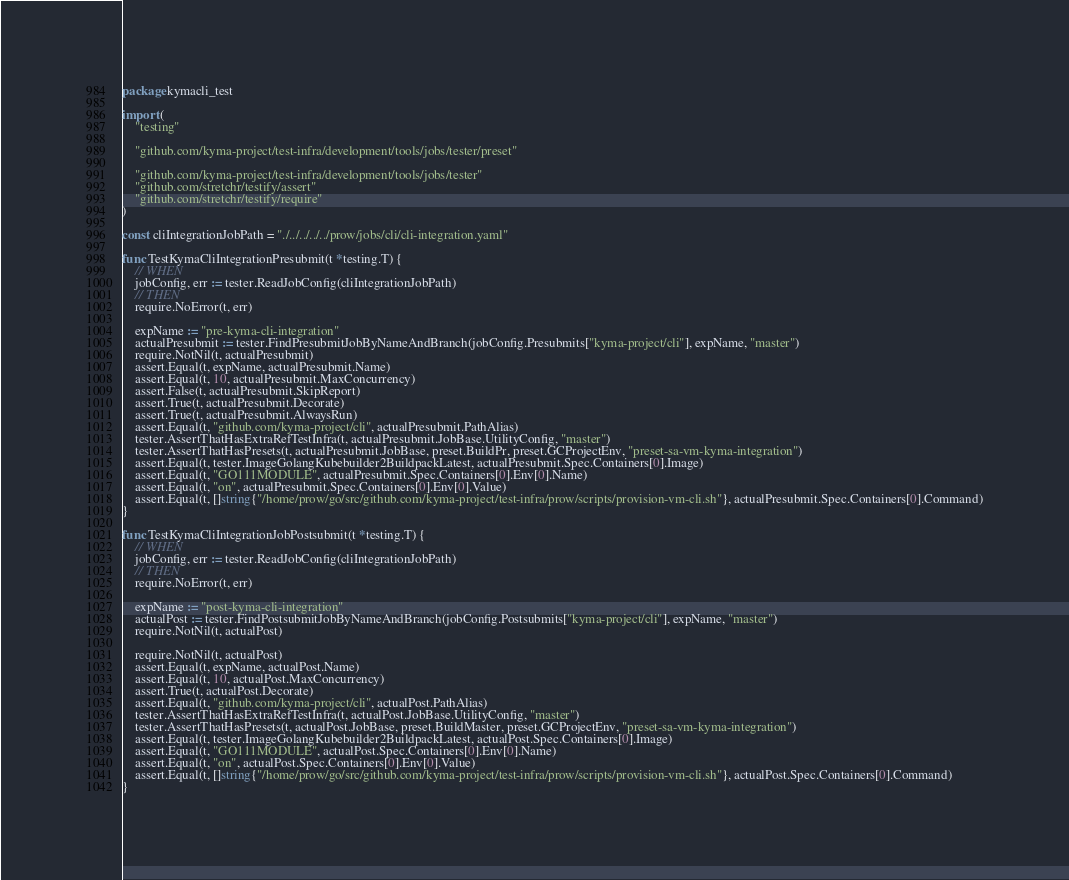<code> <loc_0><loc_0><loc_500><loc_500><_Go_>package kymacli_test

import (
	"testing"

	"github.com/kyma-project/test-infra/development/tools/jobs/tester/preset"

	"github.com/kyma-project/test-infra/development/tools/jobs/tester"
	"github.com/stretchr/testify/assert"
	"github.com/stretchr/testify/require"
)

const cliIntegrationJobPath = "./../../../../prow/jobs/cli/cli-integration.yaml"

func TestKymaCliIntegrationPresubmit(t *testing.T) {
	// WHEN
	jobConfig, err := tester.ReadJobConfig(cliIntegrationJobPath)
	// THEN
	require.NoError(t, err)

	expName := "pre-kyma-cli-integration"
	actualPresubmit := tester.FindPresubmitJobByNameAndBranch(jobConfig.Presubmits["kyma-project/cli"], expName, "master")
	require.NotNil(t, actualPresubmit)
	assert.Equal(t, expName, actualPresubmit.Name)
	assert.Equal(t, 10, actualPresubmit.MaxConcurrency)
	assert.False(t, actualPresubmit.SkipReport)
	assert.True(t, actualPresubmit.Decorate)
	assert.True(t, actualPresubmit.AlwaysRun)
	assert.Equal(t, "github.com/kyma-project/cli", actualPresubmit.PathAlias)
	tester.AssertThatHasExtraRefTestInfra(t, actualPresubmit.JobBase.UtilityConfig, "master")
	tester.AssertThatHasPresets(t, actualPresubmit.JobBase, preset.BuildPr, preset.GCProjectEnv, "preset-sa-vm-kyma-integration")
	assert.Equal(t, tester.ImageGolangKubebuilder2BuildpackLatest, actualPresubmit.Spec.Containers[0].Image)
	assert.Equal(t, "GO111MODULE", actualPresubmit.Spec.Containers[0].Env[0].Name)
	assert.Equal(t, "on", actualPresubmit.Spec.Containers[0].Env[0].Value)
	assert.Equal(t, []string{"/home/prow/go/src/github.com/kyma-project/test-infra/prow/scripts/provision-vm-cli.sh"}, actualPresubmit.Spec.Containers[0].Command)
}

func TestKymaCliIntegrationJobPostsubmit(t *testing.T) {
	// WHEN
	jobConfig, err := tester.ReadJobConfig(cliIntegrationJobPath)
	// THEN
	require.NoError(t, err)

	expName := "post-kyma-cli-integration"
	actualPost := tester.FindPostsubmitJobByNameAndBranch(jobConfig.Postsubmits["kyma-project/cli"], expName, "master")
	require.NotNil(t, actualPost)

	require.NotNil(t, actualPost)
	assert.Equal(t, expName, actualPost.Name)
	assert.Equal(t, 10, actualPost.MaxConcurrency)
	assert.True(t, actualPost.Decorate)
	assert.Equal(t, "github.com/kyma-project/cli", actualPost.PathAlias)
	tester.AssertThatHasExtraRefTestInfra(t, actualPost.JobBase.UtilityConfig, "master")
	tester.AssertThatHasPresets(t, actualPost.JobBase, preset.BuildMaster, preset.GCProjectEnv, "preset-sa-vm-kyma-integration")
	assert.Equal(t, tester.ImageGolangKubebuilder2BuildpackLatest, actualPost.Spec.Containers[0].Image)
	assert.Equal(t, "GO111MODULE", actualPost.Spec.Containers[0].Env[0].Name)
	assert.Equal(t, "on", actualPost.Spec.Containers[0].Env[0].Value)
	assert.Equal(t, []string{"/home/prow/go/src/github.com/kyma-project/test-infra/prow/scripts/provision-vm-cli.sh"}, actualPost.Spec.Containers[0].Command)
}
</code> 